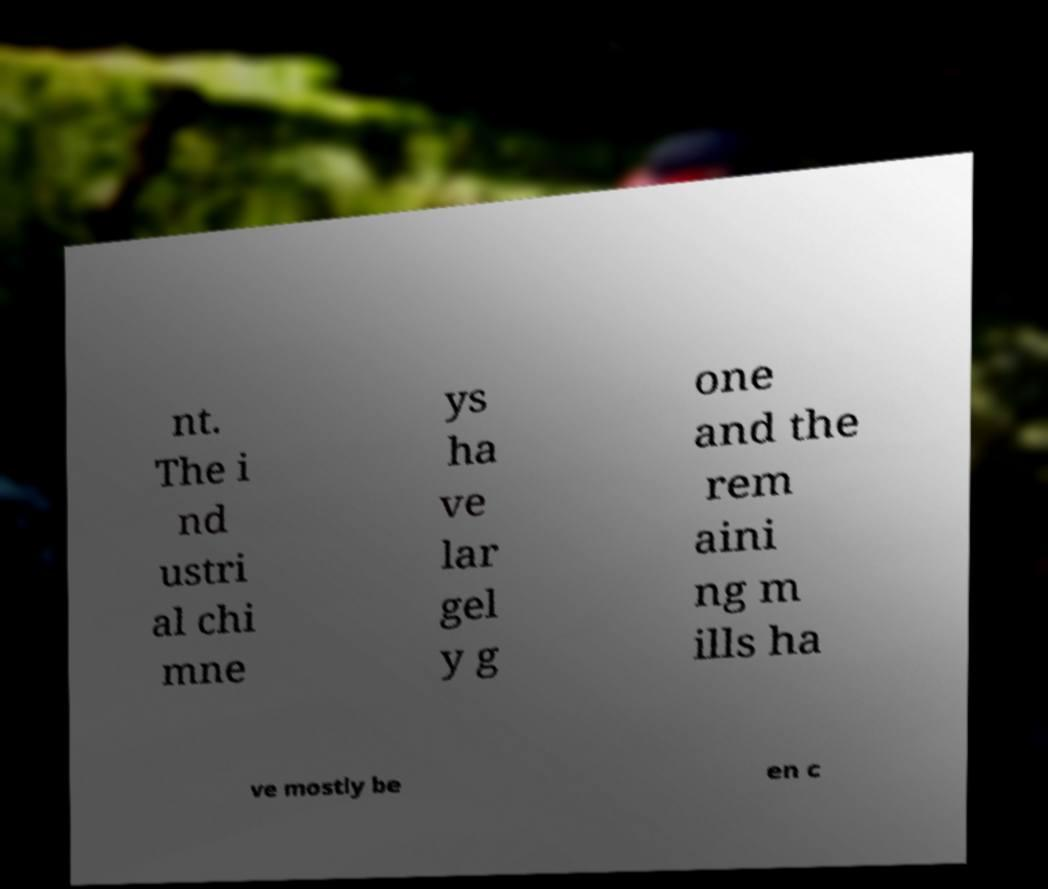I need the written content from this picture converted into text. Can you do that? nt. The i nd ustri al chi mne ys ha ve lar gel y g one and the rem aini ng m ills ha ve mostly be en c 